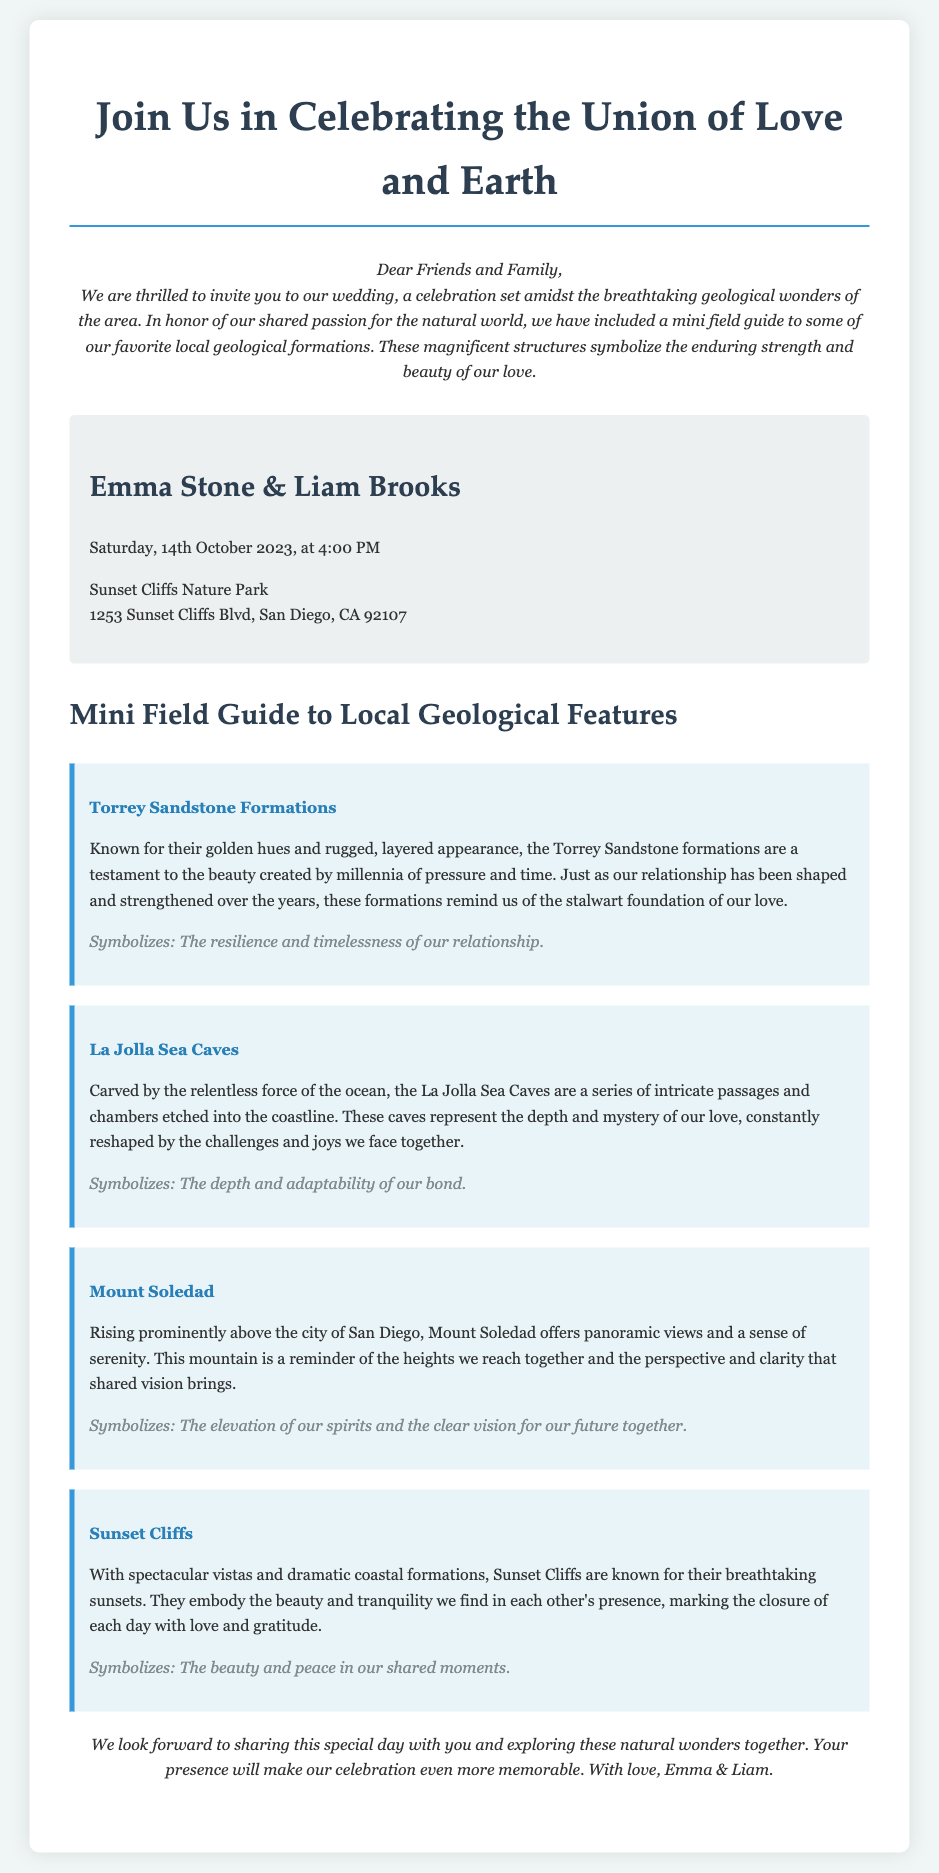What is the couple's name? The couple's names are explicitly stated in the invitation section of the document.
Answer: Emma Stone & Liam Brooks What is the wedding date? The document provides the specific date of the wedding in the details section.
Answer: Saturday, 14th October 2023 Where will the wedding take place? The location of the wedding is mentioned along with the address in the details section.
Answer: Sunset Cliffs Nature Park What geological feature symbolizes resilience and timelessness? The document associates certain symbols with specific geological features, allowing us to answer this question.
Answer: Torrey Sandstone Formations What do the La Jolla Sea Caves represent? The document connects each feature to a symbolic meaning, which is stated in their individual descriptions.
Answer: The depth and adaptability of our bond What is the significance of Sunset Cliffs in the invitation? The invitation provides a symbolic description of Sunset Cliffs, revealing its meaning in the context of the couple's love.
Answer: The beauty and peace in our shared moments Which geological feature is noted for its panoramic views? The document details various geophysical features and their characteristics, allowing for this identification.
Answer: Mount Soledad What type of document is this? The distinct characteristics and content of the document inform the identification of its type.
Answer: Wedding invitation 